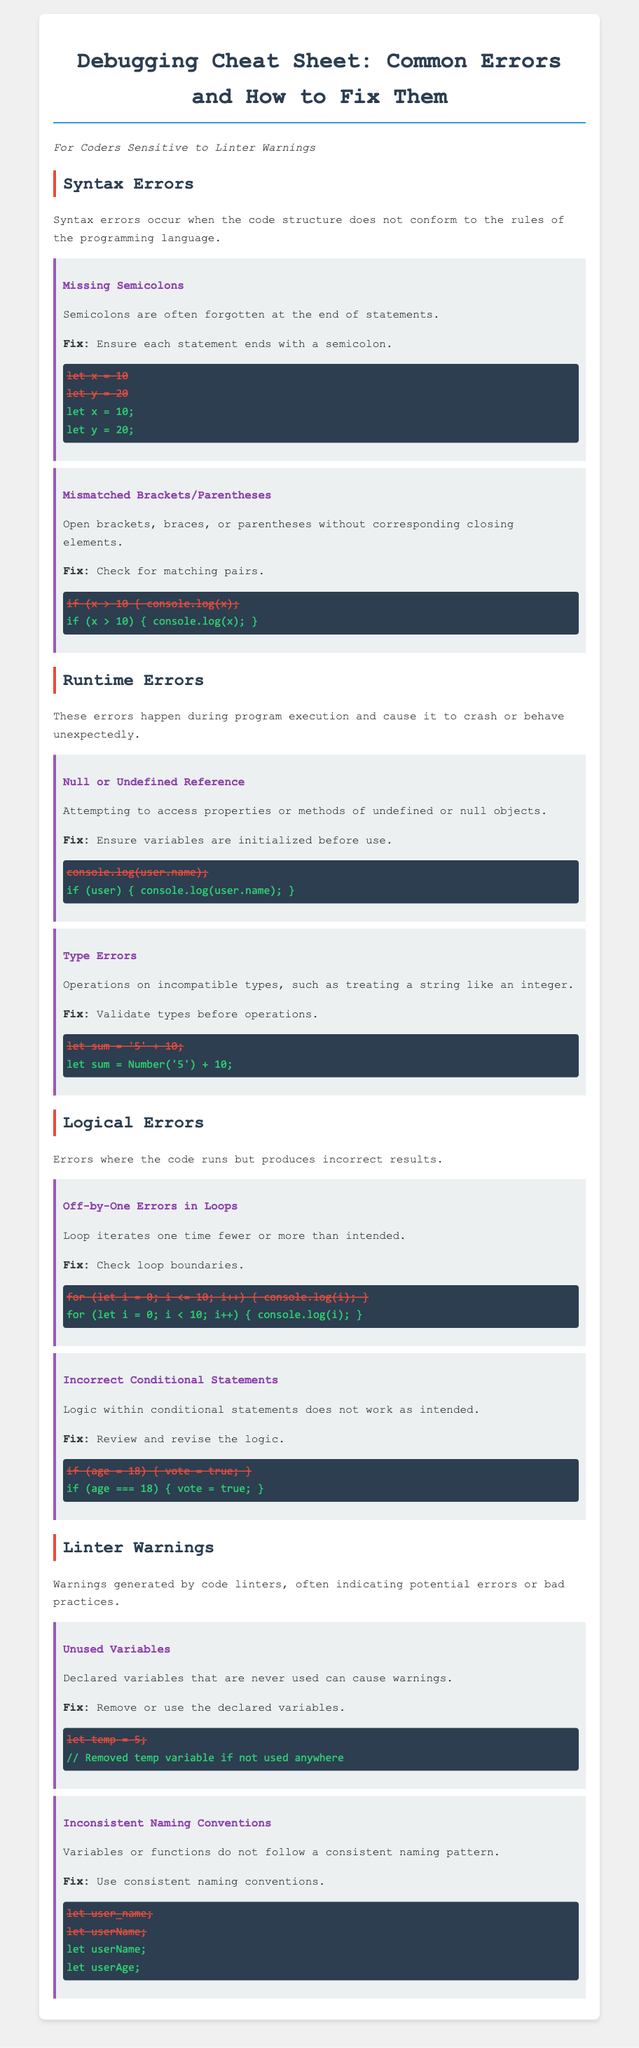What are syntax errors? Syntax errors occur when the code structure does not conform to the rules of the programming language.
Answer: Code structure violation What is a common mistake with semicolons? A common mistake is forgetting semicolons at the end of statements.
Answer: Missing semicolons What should be checked for mismatched brackets? You should check for matching pairs of brackets, braces, or parentheses.
Answer: Matching pairs What are off-by-one errors related to? Off-by-one errors are related to loop iterations that are one time fewer or more than intended.
Answer: Loop iterations What is a common linter warning related to variables? A common warning is about unused variables that are declared but never used.
Answer: Unused variables How can inconsistent naming conventions be fixed? Inconsistent naming conventions can be fixed by using consistent naming patterns.
Answer: Consistent naming What should you do if a variable is not used anywhere? You should remove the variable if it is not used anywhere.
Answer: Remove the variable What is the fix for accessing properties of undefined objects? The fix is to ensure variables are initialized before use.
Answer: Variables initialization 